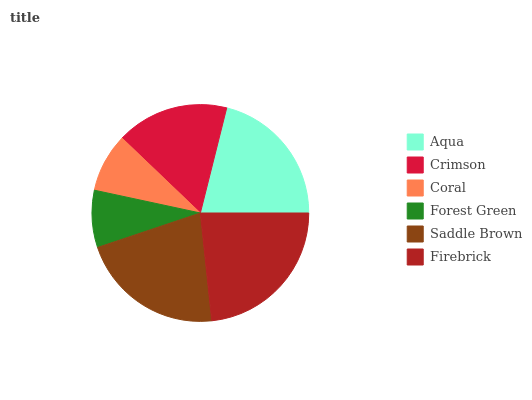Is Forest Green the minimum?
Answer yes or no. Yes. Is Firebrick the maximum?
Answer yes or no. Yes. Is Crimson the minimum?
Answer yes or no. No. Is Crimson the maximum?
Answer yes or no. No. Is Aqua greater than Crimson?
Answer yes or no. Yes. Is Crimson less than Aqua?
Answer yes or no. Yes. Is Crimson greater than Aqua?
Answer yes or no. No. Is Aqua less than Crimson?
Answer yes or no. No. Is Aqua the high median?
Answer yes or no. Yes. Is Crimson the low median?
Answer yes or no. Yes. Is Forest Green the high median?
Answer yes or no. No. Is Coral the low median?
Answer yes or no. No. 